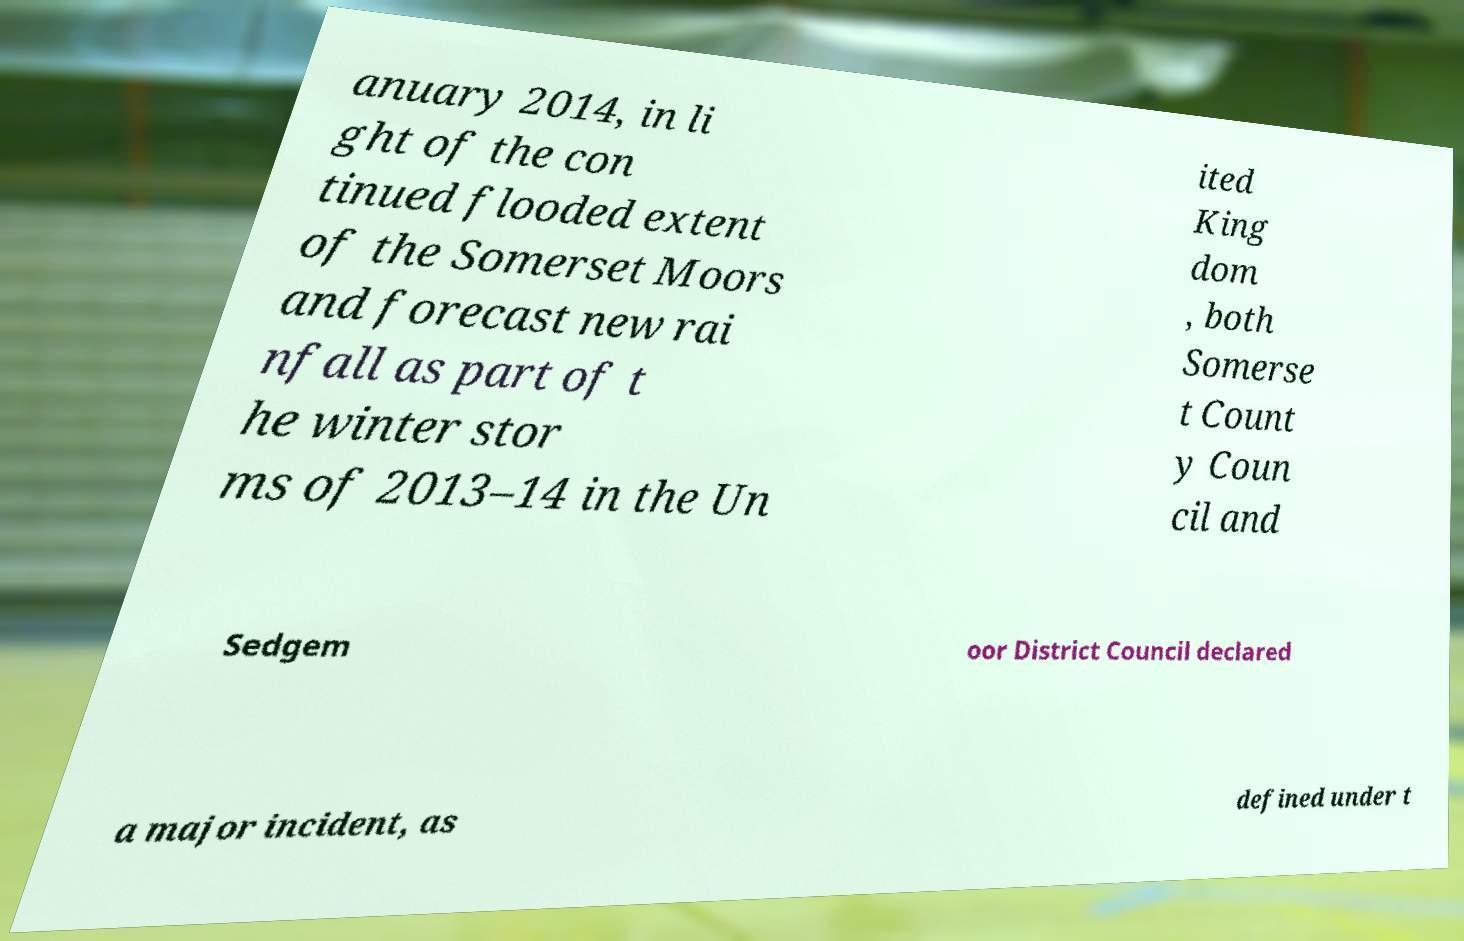I need the written content from this picture converted into text. Can you do that? anuary 2014, in li ght of the con tinued flooded extent of the Somerset Moors and forecast new rai nfall as part of t he winter stor ms of 2013–14 in the Un ited King dom , both Somerse t Count y Coun cil and Sedgem oor District Council declared a major incident, as defined under t 